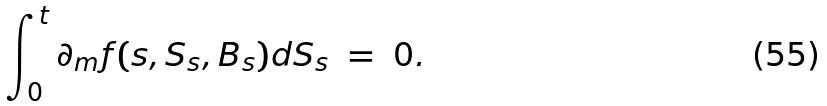<formula> <loc_0><loc_0><loc_500><loc_500>\int _ { 0 } ^ { t } \partial _ { m } f ( s , S _ { s } , B _ { s } ) d S _ { s } \ = \ 0 .</formula> 